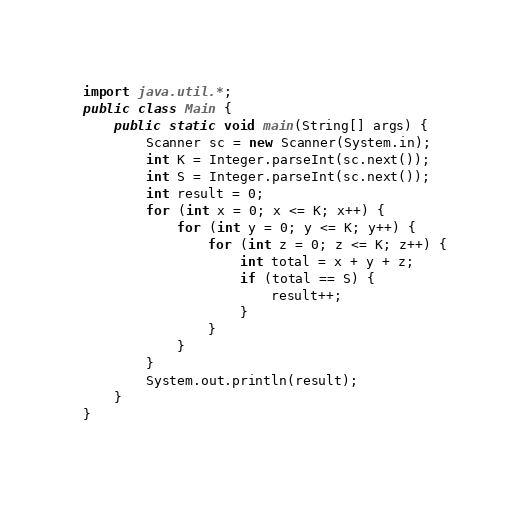<code> <loc_0><loc_0><loc_500><loc_500><_Java_>import java.util.*;
public class Main {
	public static void main(String[] args) {
		Scanner sc = new Scanner(System.in);
		int K = Integer.parseInt(sc.next());
		int S = Integer.parseInt(sc.next());
		int result = 0;
		for (int x = 0; x <= K; x++) {
			for (int y = 0; y <= K; y++) {
				for (int z = 0; z <= K; z++) {
					int total = x + y + z;
					if (total == S) {
						result++;
					}
				}
			}
		}
		System.out.println(result);
	}
}
</code> 